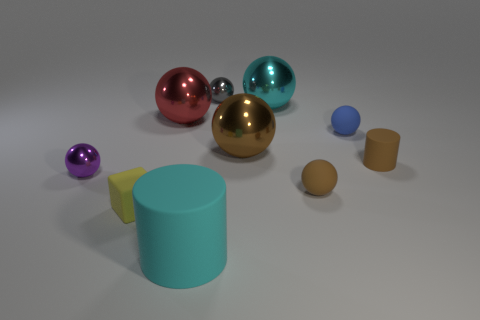There is a cyan thing that is the same shape as the red thing; what is it made of?
Offer a very short reply. Metal. There is a matte object in front of the tiny rubber block; what number of tiny gray spheres are on the right side of it?
Offer a terse response. 1. Are there any other things of the same color as the large cylinder?
Your answer should be compact. Yes. What number of things are small red cylinders or rubber spheres behind the small purple metal ball?
Your response must be concise. 1. There is a large cyan thing that is in front of the small matte thing behind the cylinder that is on the right side of the large cylinder; what is it made of?
Provide a short and direct response. Rubber. What size is the yellow object that is the same material as the tiny brown sphere?
Offer a terse response. Small. The small matte sphere right of the brown ball right of the cyan sphere is what color?
Provide a succinct answer. Blue. What number of large cyan spheres are the same material as the gray sphere?
Provide a short and direct response. 1. What number of metallic things are either large cyan objects or red balls?
Keep it short and to the point. 2. There is a purple sphere that is the same size as the brown rubber cylinder; what material is it?
Give a very brief answer. Metal. 